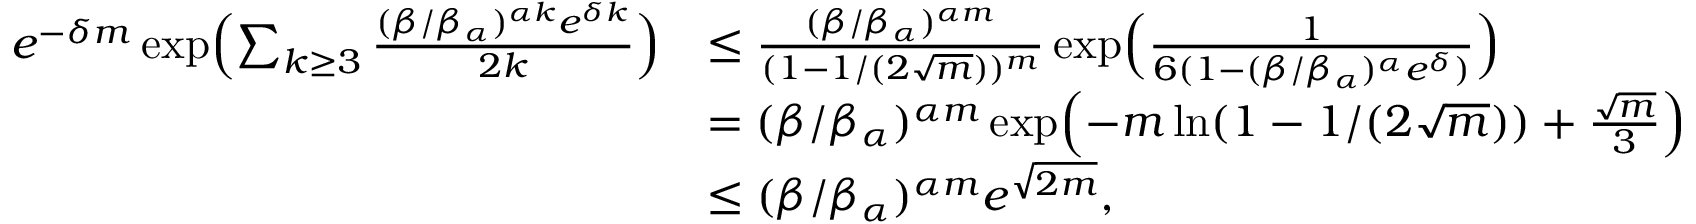Convert formula to latex. <formula><loc_0><loc_0><loc_500><loc_500>\begin{array} { r l } { e ^ { - \delta m } \exp \left ( \sum _ { k \geq 3 } \frac { ( \beta / \beta _ { \alpha } ) ^ { \alpha k } e ^ { \delta k } } { 2 k } \right ) } & { \leq \frac { ( \beta / \beta _ { \alpha } ) ^ { \alpha m } } { ( 1 - 1 / ( 2 \sqrt { m } ) ) ^ { m } } \exp \left ( \frac { 1 } { 6 ( 1 - ( \beta / \beta _ { \alpha } ) ^ { \alpha } e ^ { \delta } ) } \right ) } \\ & { = ( \beta / \beta _ { \alpha } ) ^ { \alpha m } \exp \left ( - m \ln ( 1 - 1 / ( 2 \sqrt { m } ) ) + \frac { \sqrt { m } } { 3 } \right ) } \\ & { \leq ( \beta / \beta _ { \alpha } ) ^ { \alpha m } e ^ { \sqrt { 2 m } } , } \end{array}</formula> 